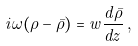Convert formula to latex. <formula><loc_0><loc_0><loc_500><loc_500>i \omega ( \rho - \bar { \rho } ) = w \frac { d \bar { \rho } } { d z } \, ,</formula> 